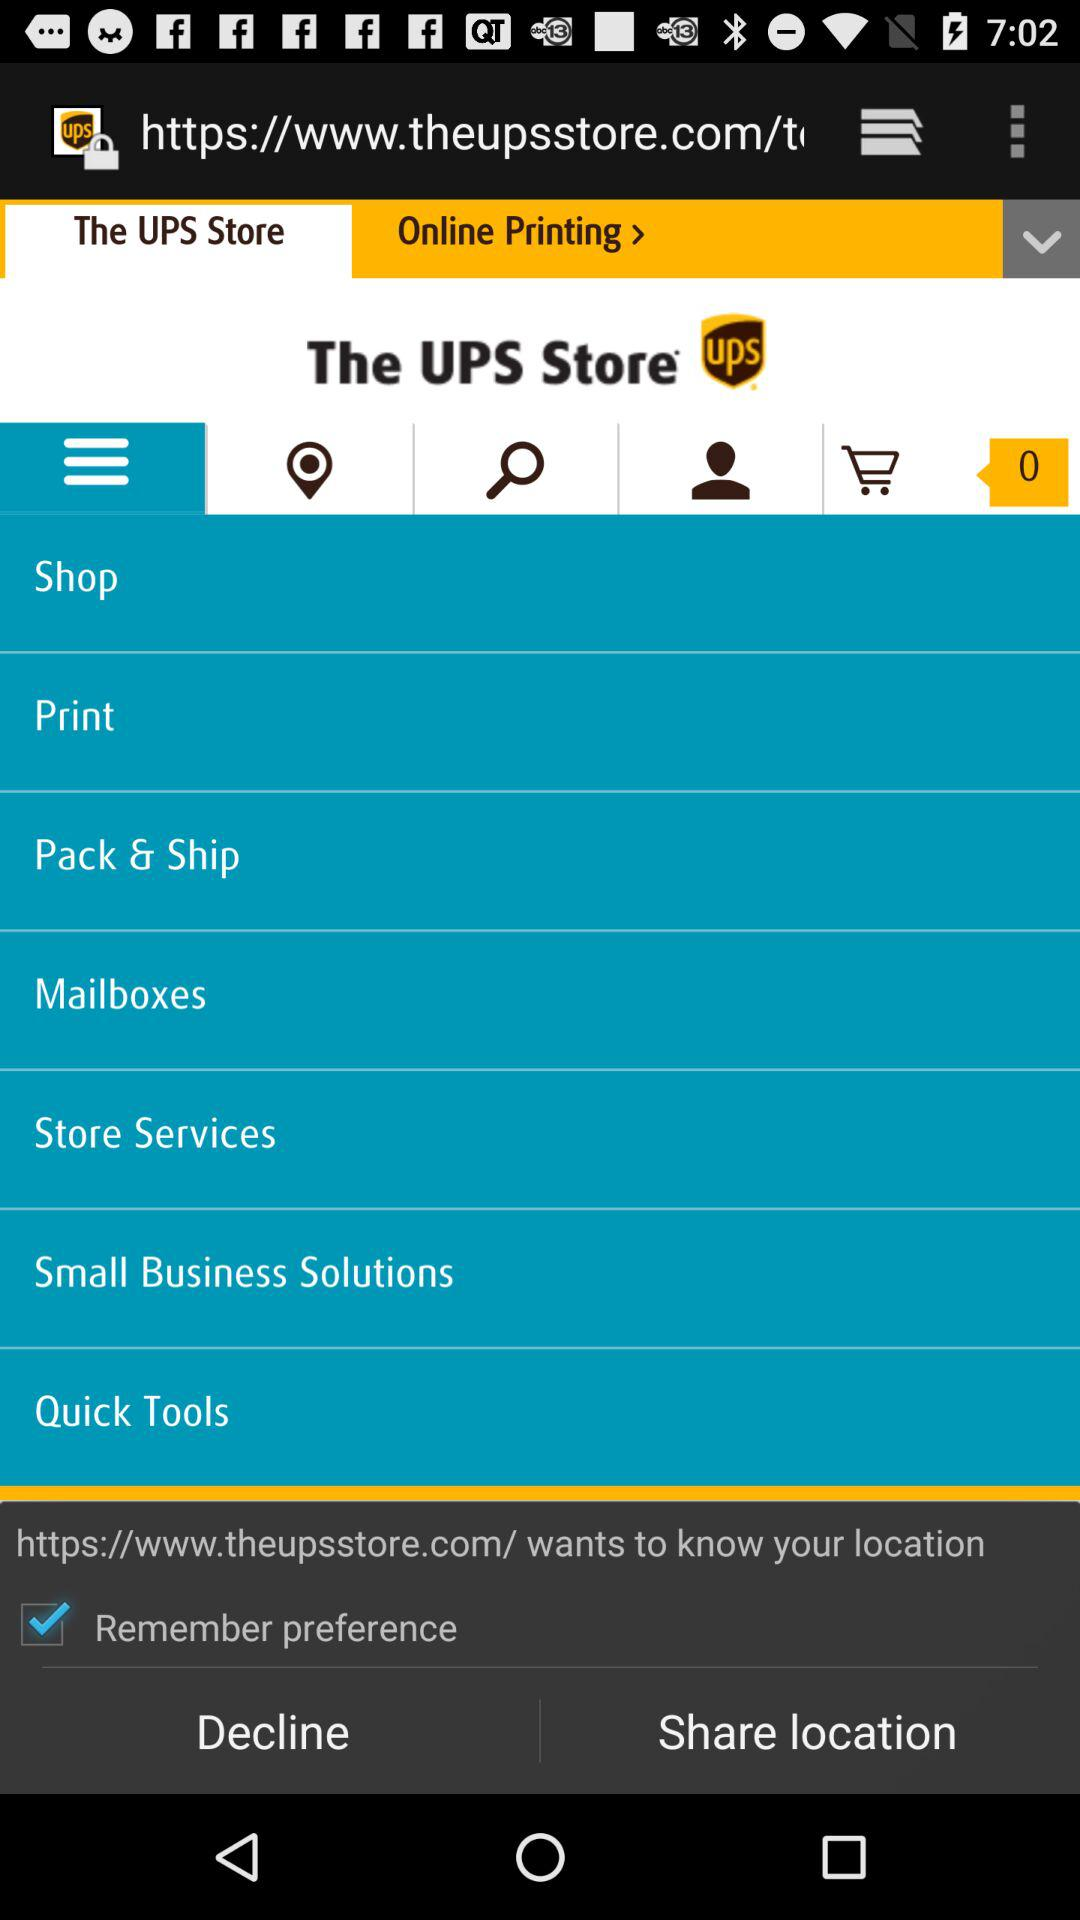What is the status of "Remember preference"? The status of "Remember preference" is "on". 